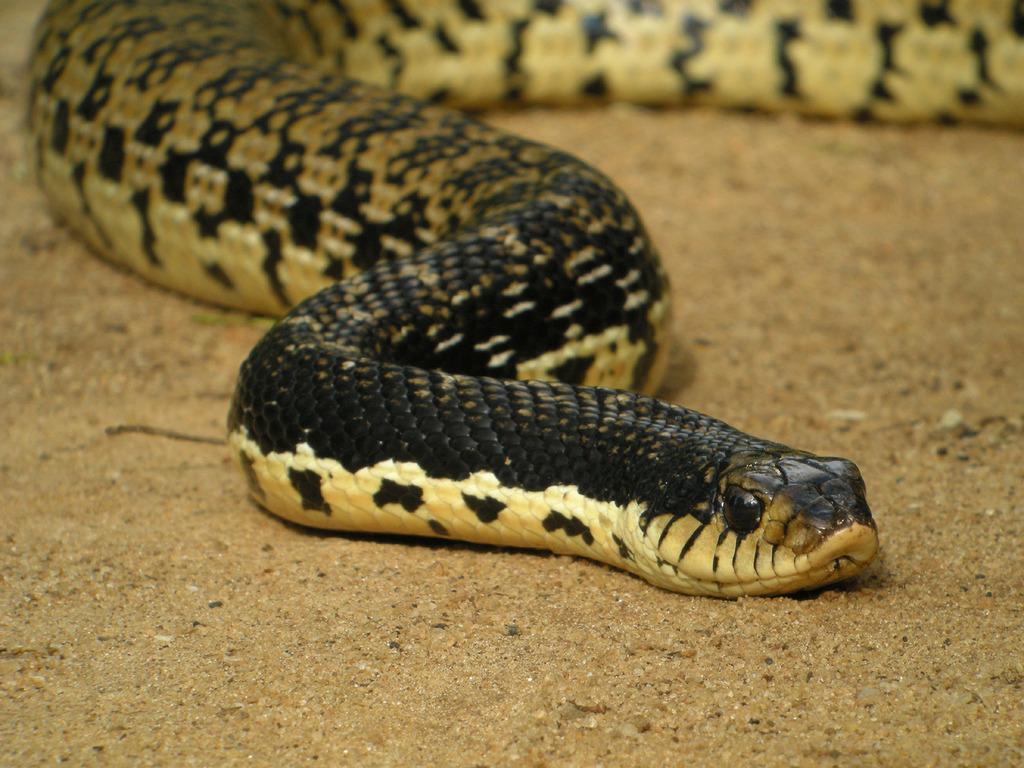In one or two sentences, can you explain what this image depicts? In this image I can see the ground which is brown in color and on it I can see a snake which is cream, black and brown in color. 